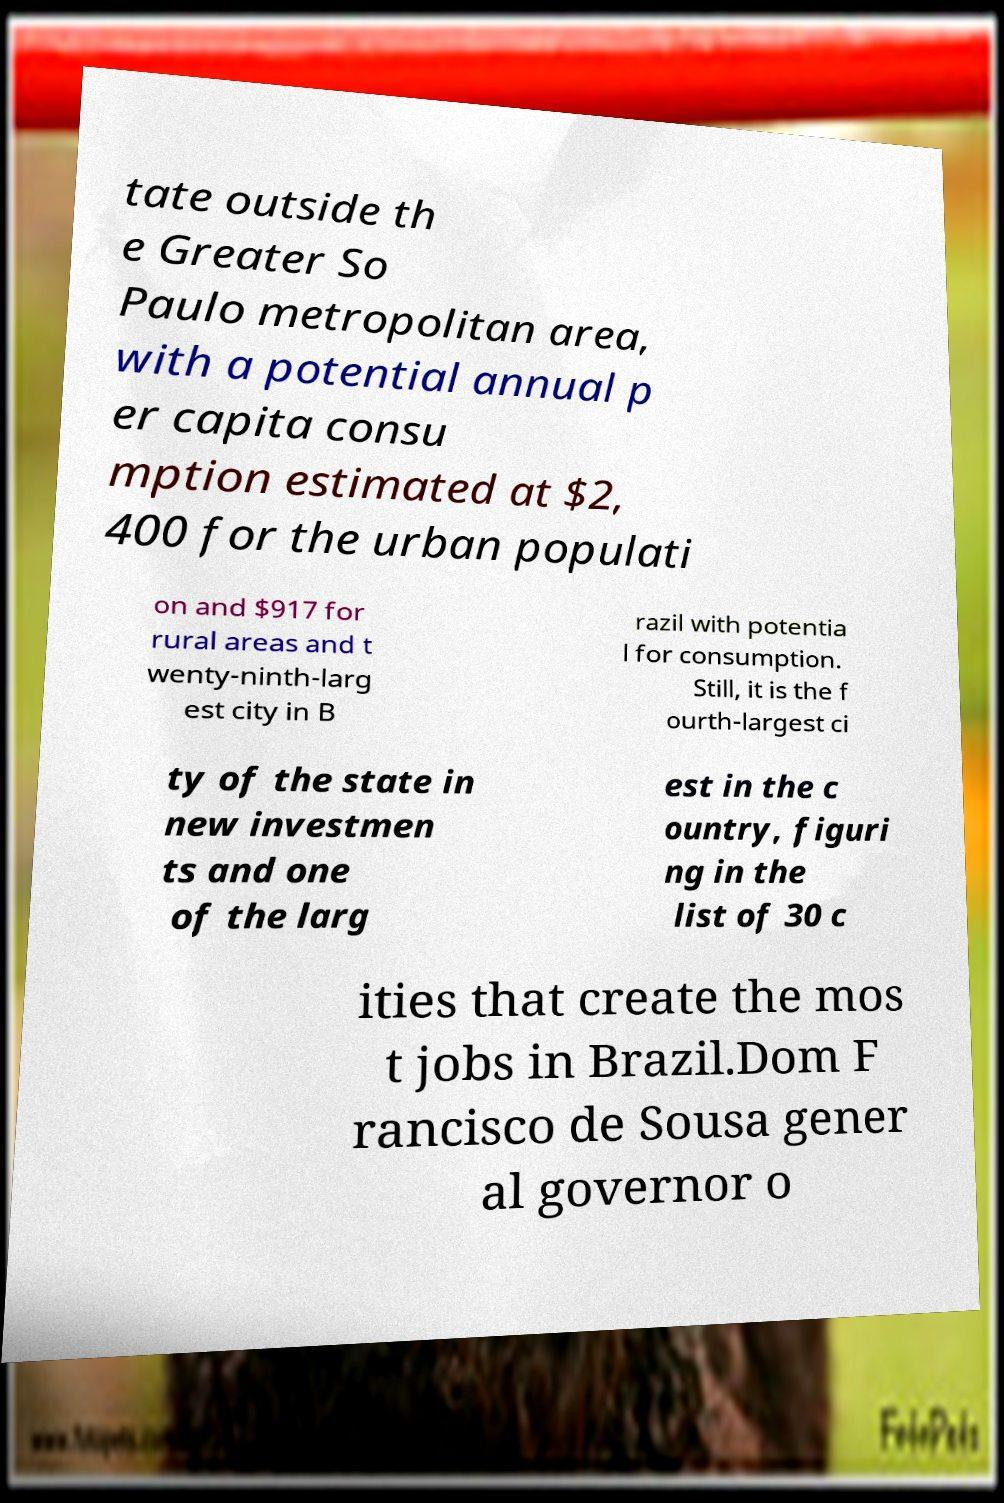What messages or text are displayed in this image? I need them in a readable, typed format. tate outside th e Greater So Paulo metropolitan area, with a potential annual p er capita consu mption estimated at $2, 400 for the urban populati on and $917 for rural areas and t wenty-ninth-larg est city in B razil with potentia l for consumption. Still, it is the f ourth-largest ci ty of the state in new investmen ts and one of the larg est in the c ountry, figuri ng in the list of 30 c ities that create the mos t jobs in Brazil.Dom F rancisco de Sousa gener al governor o 